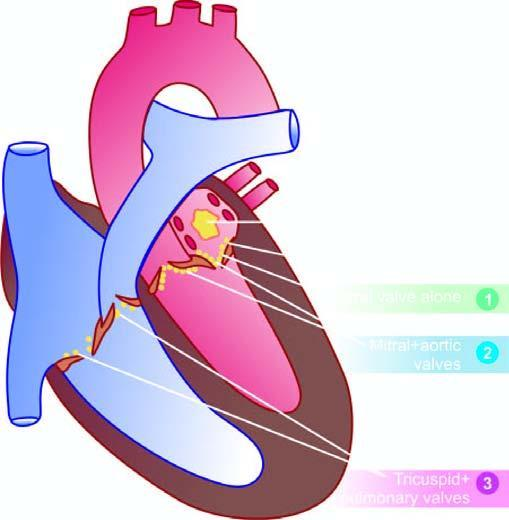s the particle denoted for the frequency of valvular involvement?
Answer the question using a single word or phrase. No 